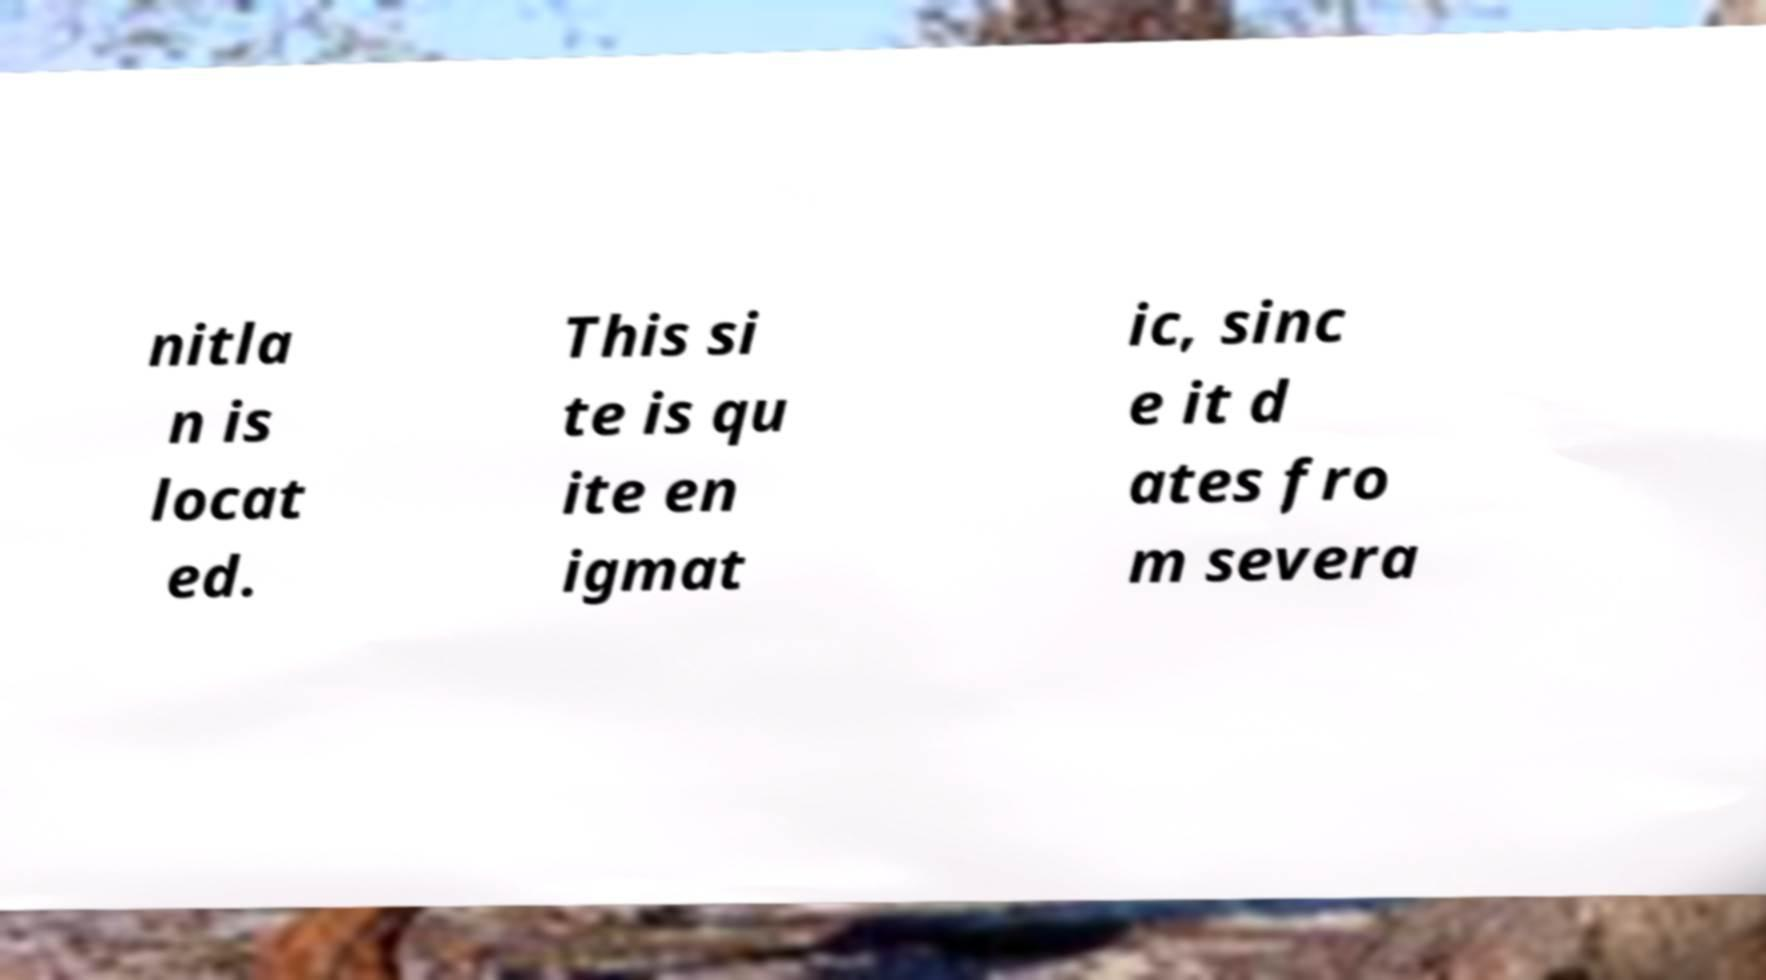What messages or text are displayed in this image? I need them in a readable, typed format. nitla n is locat ed. This si te is qu ite en igmat ic, sinc e it d ates fro m severa 